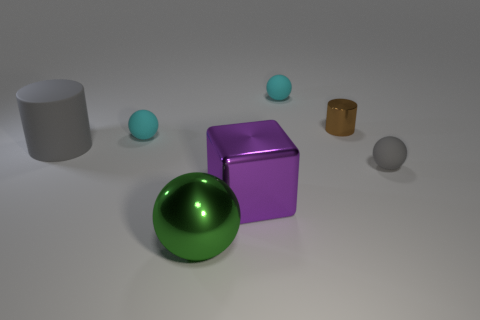Subtract all big spheres. How many spheres are left? 3 Add 2 tiny brown shiny cylinders. How many objects exist? 9 Subtract 3 spheres. How many spheres are left? 1 Subtract all cyan spheres. How many spheres are left? 2 Subtract all green balls. Subtract all green blocks. How many balls are left? 3 Subtract all gray cylinders. How many gray spheres are left? 1 Subtract all cyan rubber cylinders. Subtract all large green metallic balls. How many objects are left? 6 Add 6 large green balls. How many large green balls are left? 7 Add 4 metal blocks. How many metal blocks exist? 5 Subtract 0 cyan blocks. How many objects are left? 7 